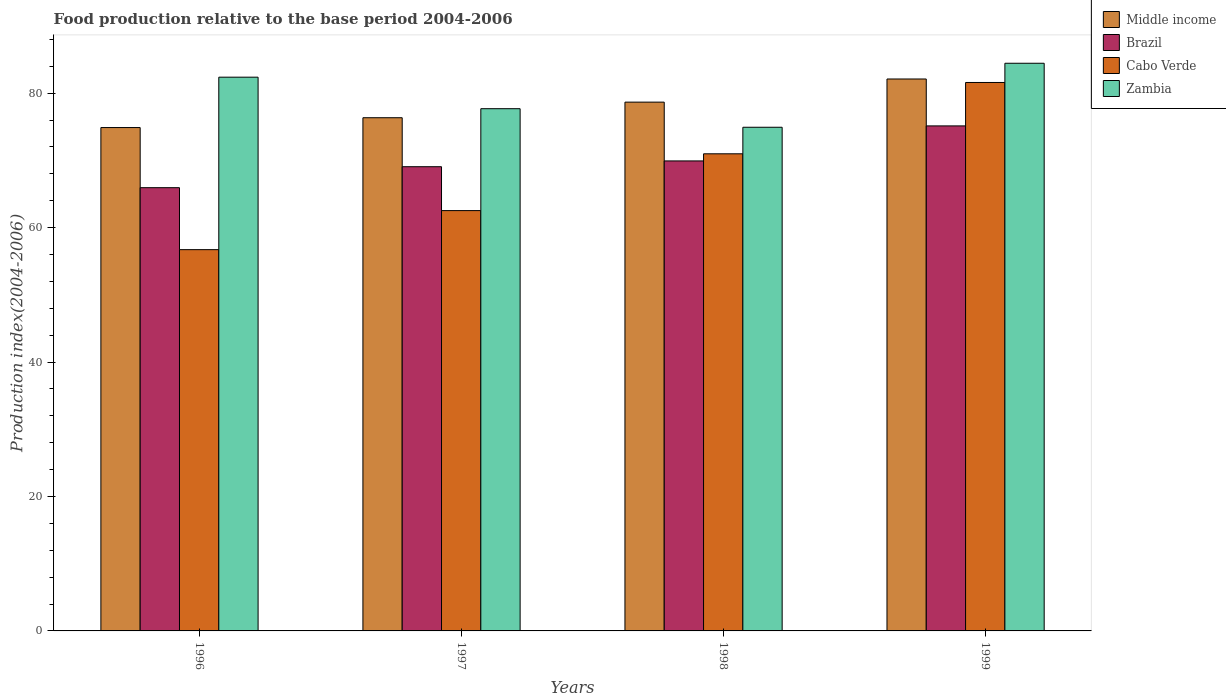How many different coloured bars are there?
Make the answer very short. 4. Are the number of bars per tick equal to the number of legend labels?
Keep it short and to the point. Yes. Are the number of bars on each tick of the X-axis equal?
Ensure brevity in your answer.  Yes. What is the food production index in Cabo Verde in 1999?
Provide a short and direct response. 81.59. Across all years, what is the maximum food production index in Cabo Verde?
Offer a very short reply. 81.59. Across all years, what is the minimum food production index in Middle income?
Your answer should be compact. 74.89. In which year was the food production index in Brazil maximum?
Give a very brief answer. 1999. In which year was the food production index in Cabo Verde minimum?
Give a very brief answer. 1996. What is the total food production index in Zambia in the graph?
Your answer should be very brief. 319.45. What is the difference between the food production index in Cabo Verde in 1996 and that in 1999?
Your response must be concise. -24.87. What is the difference between the food production index in Zambia in 1997 and the food production index in Cabo Verde in 1996?
Offer a very short reply. 20.97. What is the average food production index in Brazil per year?
Provide a succinct answer. 70.01. In the year 1998, what is the difference between the food production index in Brazil and food production index in Middle income?
Your answer should be very brief. -8.75. What is the ratio of the food production index in Cabo Verde in 1996 to that in 1998?
Your response must be concise. 0.8. Is the difference between the food production index in Brazil in 1996 and 1998 greater than the difference between the food production index in Middle income in 1996 and 1998?
Your answer should be very brief. No. What is the difference between the highest and the second highest food production index in Middle income?
Your answer should be very brief. 3.44. What is the difference between the highest and the lowest food production index in Middle income?
Your answer should be compact. 7.22. In how many years, is the food production index in Zambia greater than the average food production index in Zambia taken over all years?
Make the answer very short. 2. Is it the case that in every year, the sum of the food production index in Cabo Verde and food production index in Brazil is greater than the sum of food production index in Middle income and food production index in Zambia?
Make the answer very short. No. What does the 3rd bar from the left in 1997 represents?
Provide a short and direct response. Cabo Verde. What does the 4th bar from the right in 1999 represents?
Give a very brief answer. Middle income. How many bars are there?
Your response must be concise. 16. Are all the bars in the graph horizontal?
Offer a terse response. No. Are the values on the major ticks of Y-axis written in scientific E-notation?
Give a very brief answer. No. Does the graph contain any zero values?
Offer a very short reply. No. Where does the legend appear in the graph?
Ensure brevity in your answer.  Top right. How many legend labels are there?
Offer a terse response. 4. How are the legend labels stacked?
Your answer should be compact. Vertical. What is the title of the graph?
Ensure brevity in your answer.  Food production relative to the base period 2004-2006. What is the label or title of the X-axis?
Offer a terse response. Years. What is the label or title of the Y-axis?
Provide a short and direct response. Production index(2004-2006). What is the Production index(2004-2006) in Middle income in 1996?
Ensure brevity in your answer.  74.89. What is the Production index(2004-2006) of Brazil in 1996?
Make the answer very short. 65.94. What is the Production index(2004-2006) in Cabo Verde in 1996?
Make the answer very short. 56.72. What is the Production index(2004-2006) of Zambia in 1996?
Your response must be concise. 82.38. What is the Production index(2004-2006) in Middle income in 1997?
Give a very brief answer. 76.35. What is the Production index(2004-2006) in Brazil in 1997?
Your answer should be compact. 69.06. What is the Production index(2004-2006) of Cabo Verde in 1997?
Give a very brief answer. 62.53. What is the Production index(2004-2006) in Zambia in 1997?
Offer a very short reply. 77.69. What is the Production index(2004-2006) in Middle income in 1998?
Your answer should be compact. 78.67. What is the Production index(2004-2006) of Brazil in 1998?
Give a very brief answer. 69.92. What is the Production index(2004-2006) in Cabo Verde in 1998?
Offer a terse response. 70.98. What is the Production index(2004-2006) in Zambia in 1998?
Provide a succinct answer. 74.93. What is the Production index(2004-2006) of Middle income in 1999?
Keep it short and to the point. 82.11. What is the Production index(2004-2006) of Brazil in 1999?
Make the answer very short. 75.13. What is the Production index(2004-2006) in Cabo Verde in 1999?
Your answer should be very brief. 81.59. What is the Production index(2004-2006) of Zambia in 1999?
Provide a succinct answer. 84.45. Across all years, what is the maximum Production index(2004-2006) of Middle income?
Ensure brevity in your answer.  82.11. Across all years, what is the maximum Production index(2004-2006) of Brazil?
Ensure brevity in your answer.  75.13. Across all years, what is the maximum Production index(2004-2006) of Cabo Verde?
Provide a succinct answer. 81.59. Across all years, what is the maximum Production index(2004-2006) in Zambia?
Keep it short and to the point. 84.45. Across all years, what is the minimum Production index(2004-2006) of Middle income?
Make the answer very short. 74.89. Across all years, what is the minimum Production index(2004-2006) of Brazil?
Your answer should be compact. 65.94. Across all years, what is the minimum Production index(2004-2006) of Cabo Verde?
Your answer should be very brief. 56.72. Across all years, what is the minimum Production index(2004-2006) in Zambia?
Offer a terse response. 74.93. What is the total Production index(2004-2006) in Middle income in the graph?
Your answer should be very brief. 312.01. What is the total Production index(2004-2006) of Brazil in the graph?
Keep it short and to the point. 280.05. What is the total Production index(2004-2006) of Cabo Verde in the graph?
Provide a succinct answer. 271.82. What is the total Production index(2004-2006) of Zambia in the graph?
Keep it short and to the point. 319.45. What is the difference between the Production index(2004-2006) of Middle income in 1996 and that in 1997?
Offer a terse response. -1.46. What is the difference between the Production index(2004-2006) in Brazil in 1996 and that in 1997?
Your answer should be compact. -3.12. What is the difference between the Production index(2004-2006) of Cabo Verde in 1996 and that in 1997?
Make the answer very short. -5.81. What is the difference between the Production index(2004-2006) of Zambia in 1996 and that in 1997?
Your answer should be compact. 4.69. What is the difference between the Production index(2004-2006) in Middle income in 1996 and that in 1998?
Keep it short and to the point. -3.78. What is the difference between the Production index(2004-2006) of Brazil in 1996 and that in 1998?
Keep it short and to the point. -3.98. What is the difference between the Production index(2004-2006) of Cabo Verde in 1996 and that in 1998?
Your response must be concise. -14.26. What is the difference between the Production index(2004-2006) of Zambia in 1996 and that in 1998?
Provide a succinct answer. 7.45. What is the difference between the Production index(2004-2006) of Middle income in 1996 and that in 1999?
Give a very brief answer. -7.22. What is the difference between the Production index(2004-2006) in Brazil in 1996 and that in 1999?
Provide a succinct answer. -9.19. What is the difference between the Production index(2004-2006) in Cabo Verde in 1996 and that in 1999?
Provide a succinct answer. -24.87. What is the difference between the Production index(2004-2006) of Zambia in 1996 and that in 1999?
Offer a terse response. -2.07. What is the difference between the Production index(2004-2006) of Middle income in 1997 and that in 1998?
Ensure brevity in your answer.  -2.32. What is the difference between the Production index(2004-2006) in Brazil in 1997 and that in 1998?
Your answer should be compact. -0.86. What is the difference between the Production index(2004-2006) in Cabo Verde in 1997 and that in 1998?
Make the answer very short. -8.45. What is the difference between the Production index(2004-2006) in Zambia in 1997 and that in 1998?
Offer a terse response. 2.76. What is the difference between the Production index(2004-2006) of Middle income in 1997 and that in 1999?
Keep it short and to the point. -5.76. What is the difference between the Production index(2004-2006) of Brazil in 1997 and that in 1999?
Provide a succinct answer. -6.07. What is the difference between the Production index(2004-2006) of Cabo Verde in 1997 and that in 1999?
Offer a very short reply. -19.06. What is the difference between the Production index(2004-2006) in Zambia in 1997 and that in 1999?
Your response must be concise. -6.76. What is the difference between the Production index(2004-2006) of Middle income in 1998 and that in 1999?
Your response must be concise. -3.44. What is the difference between the Production index(2004-2006) in Brazil in 1998 and that in 1999?
Provide a short and direct response. -5.21. What is the difference between the Production index(2004-2006) of Cabo Verde in 1998 and that in 1999?
Keep it short and to the point. -10.61. What is the difference between the Production index(2004-2006) of Zambia in 1998 and that in 1999?
Ensure brevity in your answer.  -9.52. What is the difference between the Production index(2004-2006) of Middle income in 1996 and the Production index(2004-2006) of Brazil in 1997?
Make the answer very short. 5.83. What is the difference between the Production index(2004-2006) in Middle income in 1996 and the Production index(2004-2006) in Cabo Verde in 1997?
Offer a very short reply. 12.36. What is the difference between the Production index(2004-2006) of Middle income in 1996 and the Production index(2004-2006) of Zambia in 1997?
Your response must be concise. -2.8. What is the difference between the Production index(2004-2006) of Brazil in 1996 and the Production index(2004-2006) of Cabo Verde in 1997?
Your answer should be compact. 3.41. What is the difference between the Production index(2004-2006) of Brazil in 1996 and the Production index(2004-2006) of Zambia in 1997?
Offer a very short reply. -11.75. What is the difference between the Production index(2004-2006) of Cabo Verde in 1996 and the Production index(2004-2006) of Zambia in 1997?
Provide a short and direct response. -20.97. What is the difference between the Production index(2004-2006) in Middle income in 1996 and the Production index(2004-2006) in Brazil in 1998?
Offer a very short reply. 4.97. What is the difference between the Production index(2004-2006) of Middle income in 1996 and the Production index(2004-2006) of Cabo Verde in 1998?
Ensure brevity in your answer.  3.91. What is the difference between the Production index(2004-2006) of Middle income in 1996 and the Production index(2004-2006) of Zambia in 1998?
Ensure brevity in your answer.  -0.04. What is the difference between the Production index(2004-2006) in Brazil in 1996 and the Production index(2004-2006) in Cabo Verde in 1998?
Your answer should be very brief. -5.04. What is the difference between the Production index(2004-2006) of Brazil in 1996 and the Production index(2004-2006) of Zambia in 1998?
Provide a short and direct response. -8.99. What is the difference between the Production index(2004-2006) of Cabo Verde in 1996 and the Production index(2004-2006) of Zambia in 1998?
Offer a terse response. -18.21. What is the difference between the Production index(2004-2006) in Middle income in 1996 and the Production index(2004-2006) in Brazil in 1999?
Provide a short and direct response. -0.24. What is the difference between the Production index(2004-2006) of Middle income in 1996 and the Production index(2004-2006) of Cabo Verde in 1999?
Your response must be concise. -6.7. What is the difference between the Production index(2004-2006) of Middle income in 1996 and the Production index(2004-2006) of Zambia in 1999?
Provide a short and direct response. -9.56. What is the difference between the Production index(2004-2006) of Brazil in 1996 and the Production index(2004-2006) of Cabo Verde in 1999?
Provide a short and direct response. -15.65. What is the difference between the Production index(2004-2006) in Brazil in 1996 and the Production index(2004-2006) in Zambia in 1999?
Give a very brief answer. -18.51. What is the difference between the Production index(2004-2006) in Cabo Verde in 1996 and the Production index(2004-2006) in Zambia in 1999?
Keep it short and to the point. -27.73. What is the difference between the Production index(2004-2006) in Middle income in 1997 and the Production index(2004-2006) in Brazil in 1998?
Provide a succinct answer. 6.43. What is the difference between the Production index(2004-2006) of Middle income in 1997 and the Production index(2004-2006) of Cabo Verde in 1998?
Provide a succinct answer. 5.37. What is the difference between the Production index(2004-2006) of Middle income in 1997 and the Production index(2004-2006) of Zambia in 1998?
Your response must be concise. 1.42. What is the difference between the Production index(2004-2006) in Brazil in 1997 and the Production index(2004-2006) in Cabo Verde in 1998?
Offer a terse response. -1.92. What is the difference between the Production index(2004-2006) in Brazil in 1997 and the Production index(2004-2006) in Zambia in 1998?
Offer a very short reply. -5.87. What is the difference between the Production index(2004-2006) of Cabo Verde in 1997 and the Production index(2004-2006) of Zambia in 1998?
Offer a very short reply. -12.4. What is the difference between the Production index(2004-2006) of Middle income in 1997 and the Production index(2004-2006) of Brazil in 1999?
Make the answer very short. 1.22. What is the difference between the Production index(2004-2006) in Middle income in 1997 and the Production index(2004-2006) in Cabo Verde in 1999?
Your response must be concise. -5.24. What is the difference between the Production index(2004-2006) of Middle income in 1997 and the Production index(2004-2006) of Zambia in 1999?
Your answer should be compact. -8.1. What is the difference between the Production index(2004-2006) in Brazil in 1997 and the Production index(2004-2006) in Cabo Verde in 1999?
Provide a succinct answer. -12.53. What is the difference between the Production index(2004-2006) of Brazil in 1997 and the Production index(2004-2006) of Zambia in 1999?
Ensure brevity in your answer.  -15.39. What is the difference between the Production index(2004-2006) in Cabo Verde in 1997 and the Production index(2004-2006) in Zambia in 1999?
Your answer should be very brief. -21.92. What is the difference between the Production index(2004-2006) of Middle income in 1998 and the Production index(2004-2006) of Brazil in 1999?
Provide a succinct answer. 3.54. What is the difference between the Production index(2004-2006) of Middle income in 1998 and the Production index(2004-2006) of Cabo Verde in 1999?
Provide a succinct answer. -2.92. What is the difference between the Production index(2004-2006) of Middle income in 1998 and the Production index(2004-2006) of Zambia in 1999?
Offer a very short reply. -5.78. What is the difference between the Production index(2004-2006) of Brazil in 1998 and the Production index(2004-2006) of Cabo Verde in 1999?
Ensure brevity in your answer.  -11.67. What is the difference between the Production index(2004-2006) in Brazil in 1998 and the Production index(2004-2006) in Zambia in 1999?
Offer a terse response. -14.53. What is the difference between the Production index(2004-2006) in Cabo Verde in 1998 and the Production index(2004-2006) in Zambia in 1999?
Ensure brevity in your answer.  -13.47. What is the average Production index(2004-2006) in Middle income per year?
Ensure brevity in your answer.  78. What is the average Production index(2004-2006) of Brazil per year?
Your response must be concise. 70.01. What is the average Production index(2004-2006) in Cabo Verde per year?
Your response must be concise. 67.95. What is the average Production index(2004-2006) of Zambia per year?
Your answer should be compact. 79.86. In the year 1996, what is the difference between the Production index(2004-2006) of Middle income and Production index(2004-2006) of Brazil?
Your answer should be compact. 8.95. In the year 1996, what is the difference between the Production index(2004-2006) of Middle income and Production index(2004-2006) of Cabo Verde?
Ensure brevity in your answer.  18.17. In the year 1996, what is the difference between the Production index(2004-2006) of Middle income and Production index(2004-2006) of Zambia?
Make the answer very short. -7.49. In the year 1996, what is the difference between the Production index(2004-2006) in Brazil and Production index(2004-2006) in Cabo Verde?
Your answer should be very brief. 9.22. In the year 1996, what is the difference between the Production index(2004-2006) in Brazil and Production index(2004-2006) in Zambia?
Your response must be concise. -16.44. In the year 1996, what is the difference between the Production index(2004-2006) of Cabo Verde and Production index(2004-2006) of Zambia?
Your response must be concise. -25.66. In the year 1997, what is the difference between the Production index(2004-2006) in Middle income and Production index(2004-2006) in Brazil?
Make the answer very short. 7.29. In the year 1997, what is the difference between the Production index(2004-2006) of Middle income and Production index(2004-2006) of Cabo Verde?
Ensure brevity in your answer.  13.82. In the year 1997, what is the difference between the Production index(2004-2006) in Middle income and Production index(2004-2006) in Zambia?
Make the answer very short. -1.34. In the year 1997, what is the difference between the Production index(2004-2006) of Brazil and Production index(2004-2006) of Cabo Verde?
Your answer should be compact. 6.53. In the year 1997, what is the difference between the Production index(2004-2006) in Brazil and Production index(2004-2006) in Zambia?
Make the answer very short. -8.63. In the year 1997, what is the difference between the Production index(2004-2006) of Cabo Verde and Production index(2004-2006) of Zambia?
Your answer should be very brief. -15.16. In the year 1998, what is the difference between the Production index(2004-2006) of Middle income and Production index(2004-2006) of Brazil?
Keep it short and to the point. 8.75. In the year 1998, what is the difference between the Production index(2004-2006) in Middle income and Production index(2004-2006) in Cabo Verde?
Ensure brevity in your answer.  7.69. In the year 1998, what is the difference between the Production index(2004-2006) in Middle income and Production index(2004-2006) in Zambia?
Provide a succinct answer. 3.74. In the year 1998, what is the difference between the Production index(2004-2006) of Brazil and Production index(2004-2006) of Cabo Verde?
Give a very brief answer. -1.06. In the year 1998, what is the difference between the Production index(2004-2006) in Brazil and Production index(2004-2006) in Zambia?
Your answer should be compact. -5.01. In the year 1998, what is the difference between the Production index(2004-2006) of Cabo Verde and Production index(2004-2006) of Zambia?
Your response must be concise. -3.95. In the year 1999, what is the difference between the Production index(2004-2006) in Middle income and Production index(2004-2006) in Brazil?
Your answer should be compact. 6.98. In the year 1999, what is the difference between the Production index(2004-2006) of Middle income and Production index(2004-2006) of Cabo Verde?
Offer a very short reply. 0.52. In the year 1999, what is the difference between the Production index(2004-2006) in Middle income and Production index(2004-2006) in Zambia?
Ensure brevity in your answer.  -2.34. In the year 1999, what is the difference between the Production index(2004-2006) in Brazil and Production index(2004-2006) in Cabo Verde?
Offer a terse response. -6.46. In the year 1999, what is the difference between the Production index(2004-2006) of Brazil and Production index(2004-2006) of Zambia?
Give a very brief answer. -9.32. In the year 1999, what is the difference between the Production index(2004-2006) in Cabo Verde and Production index(2004-2006) in Zambia?
Provide a succinct answer. -2.86. What is the ratio of the Production index(2004-2006) of Middle income in 1996 to that in 1997?
Provide a short and direct response. 0.98. What is the ratio of the Production index(2004-2006) in Brazil in 1996 to that in 1997?
Provide a succinct answer. 0.95. What is the ratio of the Production index(2004-2006) of Cabo Verde in 1996 to that in 1997?
Ensure brevity in your answer.  0.91. What is the ratio of the Production index(2004-2006) in Zambia in 1996 to that in 1997?
Your answer should be very brief. 1.06. What is the ratio of the Production index(2004-2006) of Middle income in 1996 to that in 1998?
Your answer should be compact. 0.95. What is the ratio of the Production index(2004-2006) of Brazil in 1996 to that in 1998?
Make the answer very short. 0.94. What is the ratio of the Production index(2004-2006) of Cabo Verde in 1996 to that in 1998?
Provide a short and direct response. 0.8. What is the ratio of the Production index(2004-2006) in Zambia in 1996 to that in 1998?
Give a very brief answer. 1.1. What is the ratio of the Production index(2004-2006) of Middle income in 1996 to that in 1999?
Offer a very short reply. 0.91. What is the ratio of the Production index(2004-2006) in Brazil in 1996 to that in 1999?
Provide a succinct answer. 0.88. What is the ratio of the Production index(2004-2006) of Cabo Verde in 1996 to that in 1999?
Provide a short and direct response. 0.7. What is the ratio of the Production index(2004-2006) of Zambia in 1996 to that in 1999?
Your answer should be very brief. 0.98. What is the ratio of the Production index(2004-2006) of Middle income in 1997 to that in 1998?
Give a very brief answer. 0.97. What is the ratio of the Production index(2004-2006) of Brazil in 1997 to that in 1998?
Make the answer very short. 0.99. What is the ratio of the Production index(2004-2006) of Cabo Verde in 1997 to that in 1998?
Offer a very short reply. 0.88. What is the ratio of the Production index(2004-2006) in Zambia in 1997 to that in 1998?
Make the answer very short. 1.04. What is the ratio of the Production index(2004-2006) in Middle income in 1997 to that in 1999?
Ensure brevity in your answer.  0.93. What is the ratio of the Production index(2004-2006) in Brazil in 1997 to that in 1999?
Provide a succinct answer. 0.92. What is the ratio of the Production index(2004-2006) of Cabo Verde in 1997 to that in 1999?
Offer a very short reply. 0.77. What is the ratio of the Production index(2004-2006) in Zambia in 1997 to that in 1999?
Make the answer very short. 0.92. What is the ratio of the Production index(2004-2006) of Middle income in 1998 to that in 1999?
Keep it short and to the point. 0.96. What is the ratio of the Production index(2004-2006) of Brazil in 1998 to that in 1999?
Keep it short and to the point. 0.93. What is the ratio of the Production index(2004-2006) in Cabo Verde in 1998 to that in 1999?
Make the answer very short. 0.87. What is the ratio of the Production index(2004-2006) in Zambia in 1998 to that in 1999?
Your answer should be compact. 0.89. What is the difference between the highest and the second highest Production index(2004-2006) of Middle income?
Offer a very short reply. 3.44. What is the difference between the highest and the second highest Production index(2004-2006) in Brazil?
Provide a succinct answer. 5.21. What is the difference between the highest and the second highest Production index(2004-2006) in Cabo Verde?
Offer a very short reply. 10.61. What is the difference between the highest and the second highest Production index(2004-2006) in Zambia?
Provide a short and direct response. 2.07. What is the difference between the highest and the lowest Production index(2004-2006) in Middle income?
Your response must be concise. 7.22. What is the difference between the highest and the lowest Production index(2004-2006) in Brazil?
Your response must be concise. 9.19. What is the difference between the highest and the lowest Production index(2004-2006) of Cabo Verde?
Give a very brief answer. 24.87. What is the difference between the highest and the lowest Production index(2004-2006) of Zambia?
Provide a short and direct response. 9.52. 